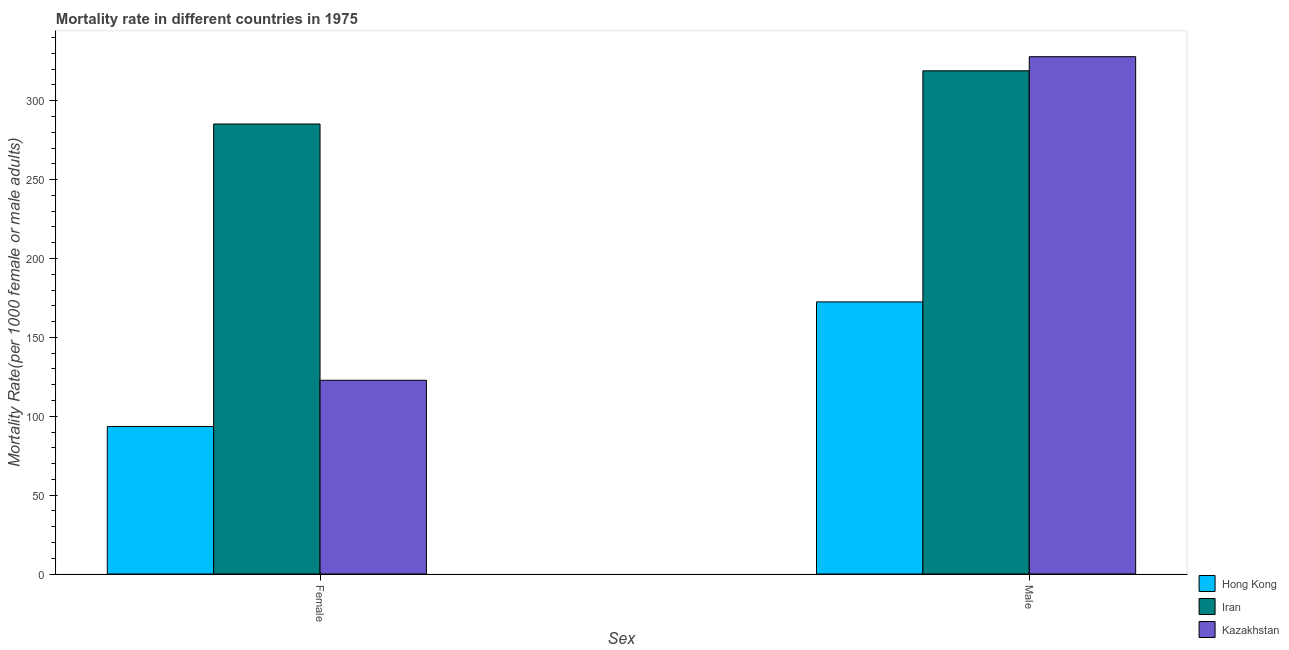How many different coloured bars are there?
Give a very brief answer. 3. Are the number of bars per tick equal to the number of legend labels?
Your response must be concise. Yes. How many bars are there on the 1st tick from the left?
Your answer should be compact. 3. How many bars are there on the 1st tick from the right?
Your answer should be very brief. 3. What is the male mortality rate in Kazakhstan?
Make the answer very short. 327.94. Across all countries, what is the maximum female mortality rate?
Your answer should be very brief. 285.27. Across all countries, what is the minimum male mortality rate?
Ensure brevity in your answer.  172.49. In which country was the female mortality rate maximum?
Provide a short and direct response. Iran. In which country was the female mortality rate minimum?
Ensure brevity in your answer.  Hong Kong. What is the total female mortality rate in the graph?
Your response must be concise. 501.57. What is the difference between the female mortality rate in Iran and that in Hong Kong?
Offer a terse response. 191.78. What is the difference between the male mortality rate in Hong Kong and the female mortality rate in Iran?
Offer a terse response. -112.78. What is the average female mortality rate per country?
Offer a terse response. 167.19. What is the difference between the male mortality rate and female mortality rate in Hong Kong?
Keep it short and to the point. 79. What is the ratio of the female mortality rate in Kazakhstan to that in Iran?
Ensure brevity in your answer.  0.43. What does the 2nd bar from the left in Female represents?
Provide a succinct answer. Iran. What does the 3rd bar from the right in Male represents?
Offer a very short reply. Hong Kong. Are all the bars in the graph horizontal?
Give a very brief answer. No. How many countries are there in the graph?
Provide a short and direct response. 3. Are the values on the major ticks of Y-axis written in scientific E-notation?
Provide a short and direct response. No. Does the graph contain grids?
Offer a terse response. No. How many legend labels are there?
Offer a terse response. 3. How are the legend labels stacked?
Ensure brevity in your answer.  Vertical. What is the title of the graph?
Keep it short and to the point. Mortality rate in different countries in 1975. What is the label or title of the X-axis?
Offer a very short reply. Sex. What is the label or title of the Y-axis?
Ensure brevity in your answer.  Mortality Rate(per 1000 female or male adults). What is the Mortality Rate(per 1000 female or male adults) of Hong Kong in Female?
Offer a very short reply. 93.49. What is the Mortality Rate(per 1000 female or male adults) in Iran in Female?
Provide a short and direct response. 285.27. What is the Mortality Rate(per 1000 female or male adults) of Kazakhstan in Female?
Your response must be concise. 122.81. What is the Mortality Rate(per 1000 female or male adults) of Hong Kong in Male?
Offer a very short reply. 172.49. What is the Mortality Rate(per 1000 female or male adults) of Iran in Male?
Keep it short and to the point. 318.99. What is the Mortality Rate(per 1000 female or male adults) in Kazakhstan in Male?
Provide a succinct answer. 327.94. Across all Sex, what is the maximum Mortality Rate(per 1000 female or male adults) in Hong Kong?
Offer a terse response. 172.49. Across all Sex, what is the maximum Mortality Rate(per 1000 female or male adults) in Iran?
Make the answer very short. 318.99. Across all Sex, what is the maximum Mortality Rate(per 1000 female or male adults) of Kazakhstan?
Give a very brief answer. 327.94. Across all Sex, what is the minimum Mortality Rate(per 1000 female or male adults) of Hong Kong?
Ensure brevity in your answer.  93.49. Across all Sex, what is the minimum Mortality Rate(per 1000 female or male adults) of Iran?
Provide a short and direct response. 285.27. Across all Sex, what is the minimum Mortality Rate(per 1000 female or male adults) of Kazakhstan?
Your answer should be very brief. 122.81. What is the total Mortality Rate(per 1000 female or male adults) in Hong Kong in the graph?
Your answer should be very brief. 265.98. What is the total Mortality Rate(per 1000 female or male adults) of Iran in the graph?
Ensure brevity in your answer.  604.27. What is the total Mortality Rate(per 1000 female or male adults) of Kazakhstan in the graph?
Ensure brevity in your answer.  450.75. What is the difference between the Mortality Rate(per 1000 female or male adults) of Hong Kong in Female and that in Male?
Your answer should be compact. -79. What is the difference between the Mortality Rate(per 1000 female or male adults) of Iran in Female and that in Male?
Make the answer very short. -33.72. What is the difference between the Mortality Rate(per 1000 female or male adults) in Kazakhstan in Female and that in Male?
Provide a succinct answer. -205.13. What is the difference between the Mortality Rate(per 1000 female or male adults) in Hong Kong in Female and the Mortality Rate(per 1000 female or male adults) in Iran in Male?
Offer a terse response. -225.5. What is the difference between the Mortality Rate(per 1000 female or male adults) of Hong Kong in Female and the Mortality Rate(per 1000 female or male adults) of Kazakhstan in Male?
Ensure brevity in your answer.  -234.44. What is the difference between the Mortality Rate(per 1000 female or male adults) of Iran in Female and the Mortality Rate(per 1000 female or male adults) of Kazakhstan in Male?
Your answer should be very brief. -42.67. What is the average Mortality Rate(per 1000 female or male adults) of Hong Kong per Sex?
Provide a succinct answer. 132.99. What is the average Mortality Rate(per 1000 female or male adults) in Iran per Sex?
Your answer should be compact. 302.13. What is the average Mortality Rate(per 1000 female or male adults) in Kazakhstan per Sex?
Give a very brief answer. 225.37. What is the difference between the Mortality Rate(per 1000 female or male adults) of Hong Kong and Mortality Rate(per 1000 female or male adults) of Iran in Female?
Offer a very short reply. -191.78. What is the difference between the Mortality Rate(per 1000 female or male adults) of Hong Kong and Mortality Rate(per 1000 female or male adults) of Kazakhstan in Female?
Provide a succinct answer. -29.31. What is the difference between the Mortality Rate(per 1000 female or male adults) in Iran and Mortality Rate(per 1000 female or male adults) in Kazakhstan in Female?
Keep it short and to the point. 162.47. What is the difference between the Mortality Rate(per 1000 female or male adults) of Hong Kong and Mortality Rate(per 1000 female or male adults) of Iran in Male?
Give a very brief answer. -146.5. What is the difference between the Mortality Rate(per 1000 female or male adults) of Hong Kong and Mortality Rate(per 1000 female or male adults) of Kazakhstan in Male?
Give a very brief answer. -155.45. What is the difference between the Mortality Rate(per 1000 female or male adults) of Iran and Mortality Rate(per 1000 female or male adults) of Kazakhstan in Male?
Keep it short and to the point. -8.94. What is the ratio of the Mortality Rate(per 1000 female or male adults) of Hong Kong in Female to that in Male?
Make the answer very short. 0.54. What is the ratio of the Mortality Rate(per 1000 female or male adults) in Iran in Female to that in Male?
Make the answer very short. 0.89. What is the ratio of the Mortality Rate(per 1000 female or male adults) of Kazakhstan in Female to that in Male?
Provide a succinct answer. 0.37. What is the difference between the highest and the second highest Mortality Rate(per 1000 female or male adults) in Hong Kong?
Provide a succinct answer. 79. What is the difference between the highest and the second highest Mortality Rate(per 1000 female or male adults) of Iran?
Provide a succinct answer. 33.72. What is the difference between the highest and the second highest Mortality Rate(per 1000 female or male adults) in Kazakhstan?
Your answer should be compact. 205.13. What is the difference between the highest and the lowest Mortality Rate(per 1000 female or male adults) of Hong Kong?
Give a very brief answer. 79. What is the difference between the highest and the lowest Mortality Rate(per 1000 female or male adults) of Iran?
Offer a very short reply. 33.72. What is the difference between the highest and the lowest Mortality Rate(per 1000 female or male adults) in Kazakhstan?
Your answer should be very brief. 205.13. 